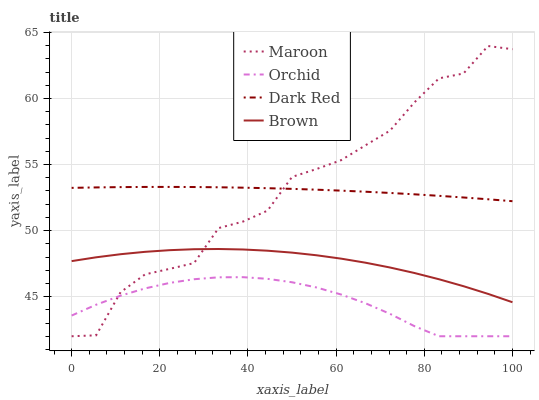Does Orchid have the minimum area under the curve?
Answer yes or no. Yes. Does Maroon have the maximum area under the curve?
Answer yes or no. Yes. Does Brown have the minimum area under the curve?
Answer yes or no. No. Does Brown have the maximum area under the curve?
Answer yes or no. No. Is Dark Red the smoothest?
Answer yes or no. Yes. Is Maroon the roughest?
Answer yes or no. Yes. Is Brown the smoothest?
Answer yes or no. No. Is Brown the roughest?
Answer yes or no. No. Does Maroon have the lowest value?
Answer yes or no. Yes. Does Brown have the lowest value?
Answer yes or no. No. Does Maroon have the highest value?
Answer yes or no. Yes. Does Brown have the highest value?
Answer yes or no. No. Is Orchid less than Dark Red?
Answer yes or no. Yes. Is Dark Red greater than Orchid?
Answer yes or no. Yes. Does Maroon intersect Brown?
Answer yes or no. Yes. Is Maroon less than Brown?
Answer yes or no. No. Is Maroon greater than Brown?
Answer yes or no. No. Does Orchid intersect Dark Red?
Answer yes or no. No. 